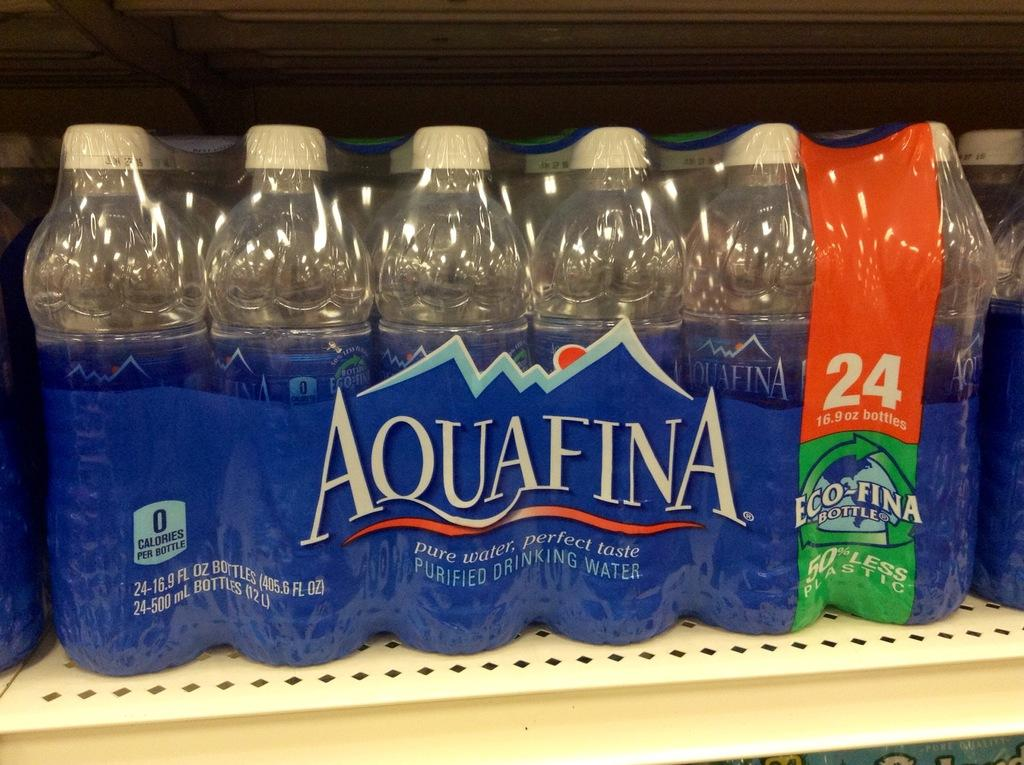<image>
Give a short and clear explanation of the subsequent image. A 24 pack of Aquafina drinking water sits on a store shelf. 